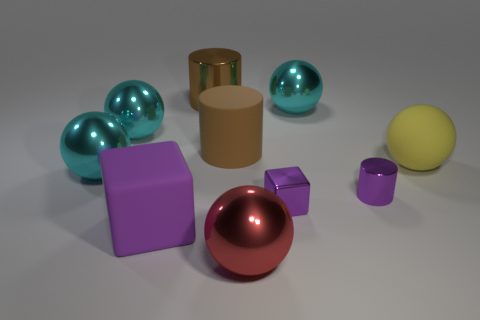What number of rubber objects are the same color as the small metallic cylinder?
Your response must be concise. 1. Are there any tiny things made of the same material as the large purple thing?
Provide a succinct answer. No. Is the number of yellow balls that are to the left of the large brown matte object greater than the number of tiny metal objects that are behind the big rubber sphere?
Provide a succinct answer. No. What is the size of the yellow matte object?
Your response must be concise. Large. There is a cyan shiny object that is to the right of the red ball; what is its shape?
Keep it short and to the point. Sphere. Do the big yellow matte thing and the brown metallic thing have the same shape?
Give a very brief answer. No. Are there the same number of big purple matte things that are right of the large brown matte object and tiny blocks?
Provide a succinct answer. No. What shape is the large purple thing?
Give a very brief answer. Cube. Are there any other things that are the same color as the matte block?
Your answer should be compact. Yes. Does the purple block that is behind the rubber cube have the same size as the metal cylinder that is left of the brown rubber cylinder?
Provide a short and direct response. No. 